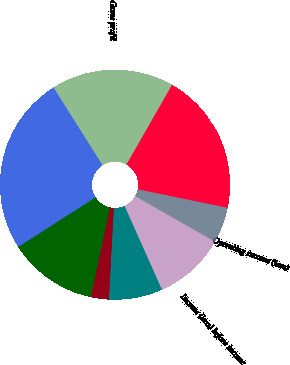Convert chart to OTSL. <chart><loc_0><loc_0><loc_500><loc_500><pie_chart><fcel>Year Ended December 31<fcel>Net sales<fcel>Gross profit<fcel>Total operating expenses<fcel>Operating income (loss)<fcel>Income (loss) before income<fcel>Net income (loss)<fcel>Basic<fcel>Assuming dilution<nl><fcel>12.56%<fcel>25.12%<fcel>17.22%<fcel>19.96%<fcel>5.03%<fcel>10.05%<fcel>7.54%<fcel>0.0%<fcel>2.51%<nl></chart> 